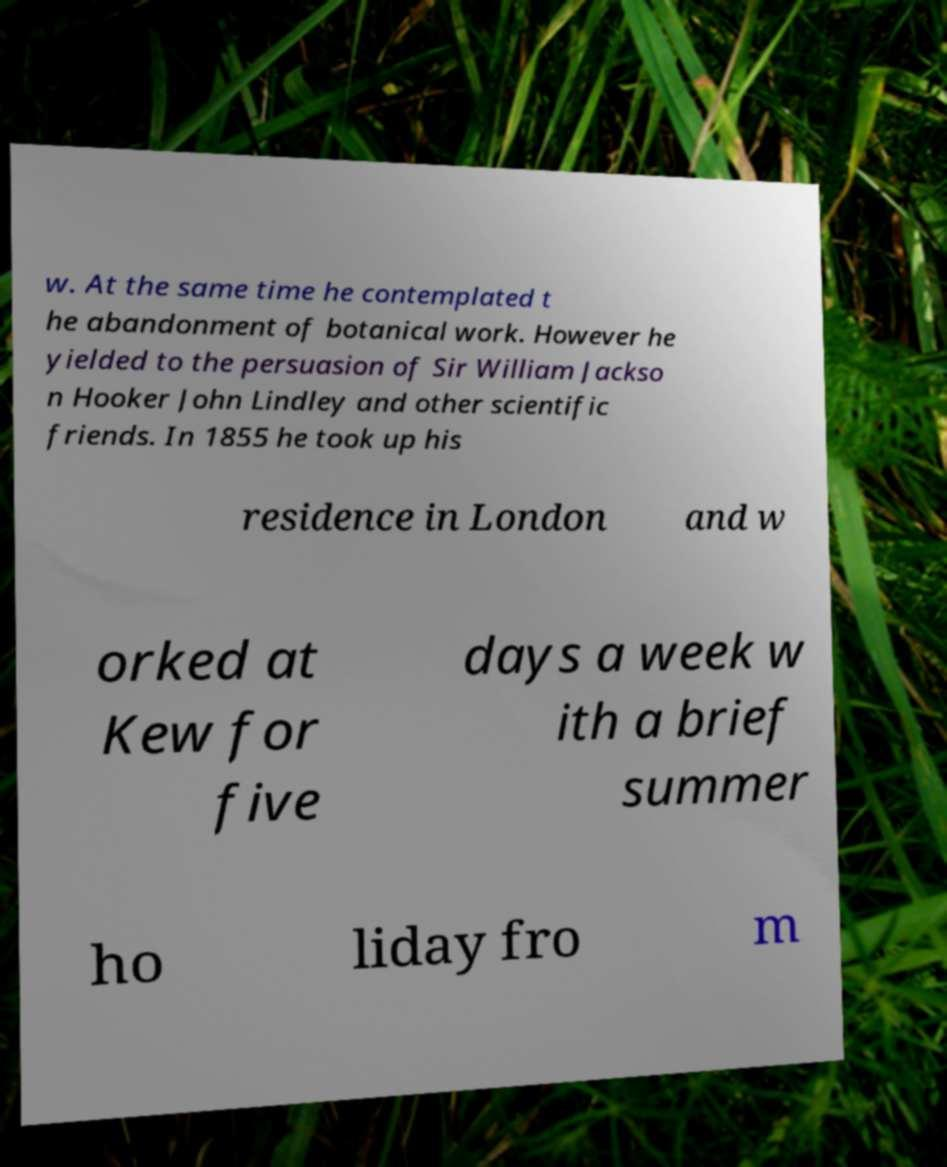Could you extract and type out the text from this image? w. At the same time he contemplated t he abandonment of botanical work. However he yielded to the persuasion of Sir William Jackso n Hooker John Lindley and other scientific friends. In 1855 he took up his residence in London and w orked at Kew for five days a week w ith a brief summer ho liday fro m 